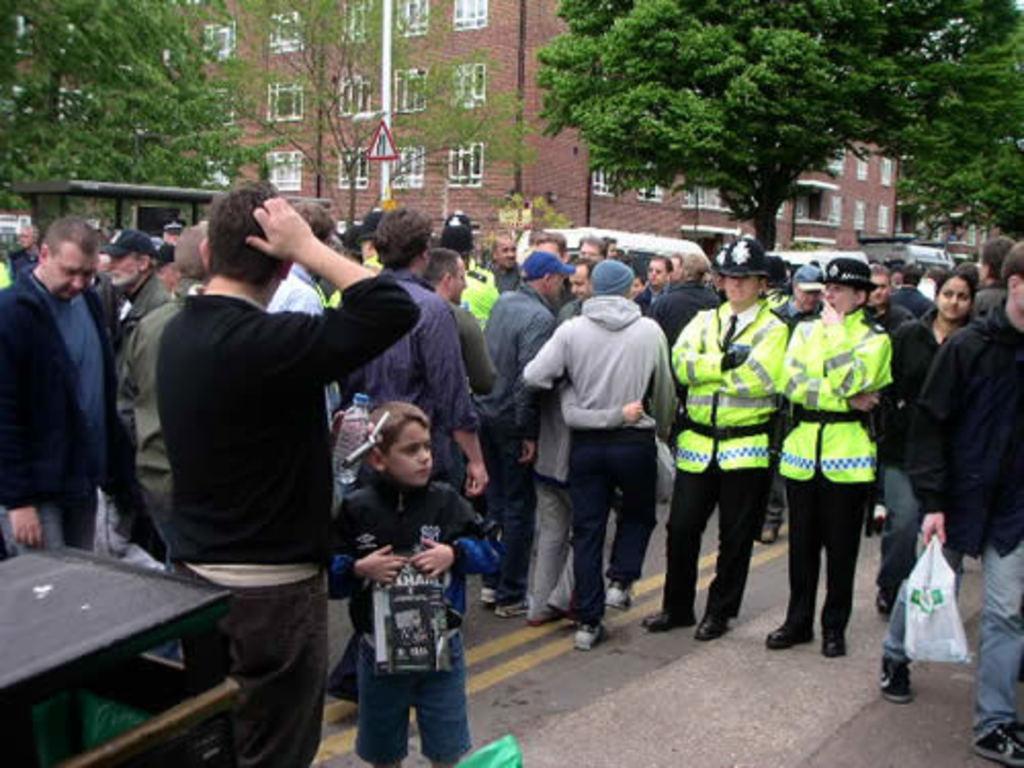Could you give a brief overview of what you see in this image? In this image I see number of people in which these 2 persons are wearing same dress and this person is holding things in his hand and this man is holding a cover in his hand and I see the road. In the background I see the buildings, vehicles, trees and a pole over here and I see the sign board over here. 